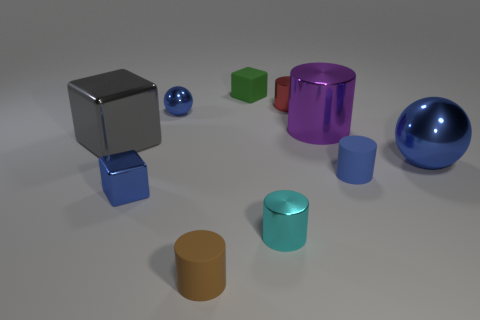What number of other things are there of the same color as the tiny metal cube?
Keep it short and to the point. 3. Does the gray block have the same material as the small cylinder behind the big metal block?
Provide a short and direct response. Yes. How many things are tiny cylinders behind the cyan metallic object or tiny purple metal cylinders?
Offer a very short reply. 2. There is a small thing that is both left of the tiny green cube and behind the big gray metallic block; what is its shape?
Provide a succinct answer. Sphere. Is there any other thing that is the same size as the gray object?
Provide a short and direct response. Yes. There is a green object that is made of the same material as the tiny brown object; what size is it?
Your answer should be compact. Small. What number of things are either spheres that are behind the gray metallic object or tiny metal cylinders that are in front of the large gray block?
Make the answer very short. 2. There is a matte object that is in front of the blue matte cylinder; does it have the same size as the small green rubber thing?
Your answer should be very brief. Yes. The metallic ball in front of the gray object is what color?
Make the answer very short. Blue. What is the color of the big metal thing that is the same shape as the tiny green matte object?
Ensure brevity in your answer.  Gray. 